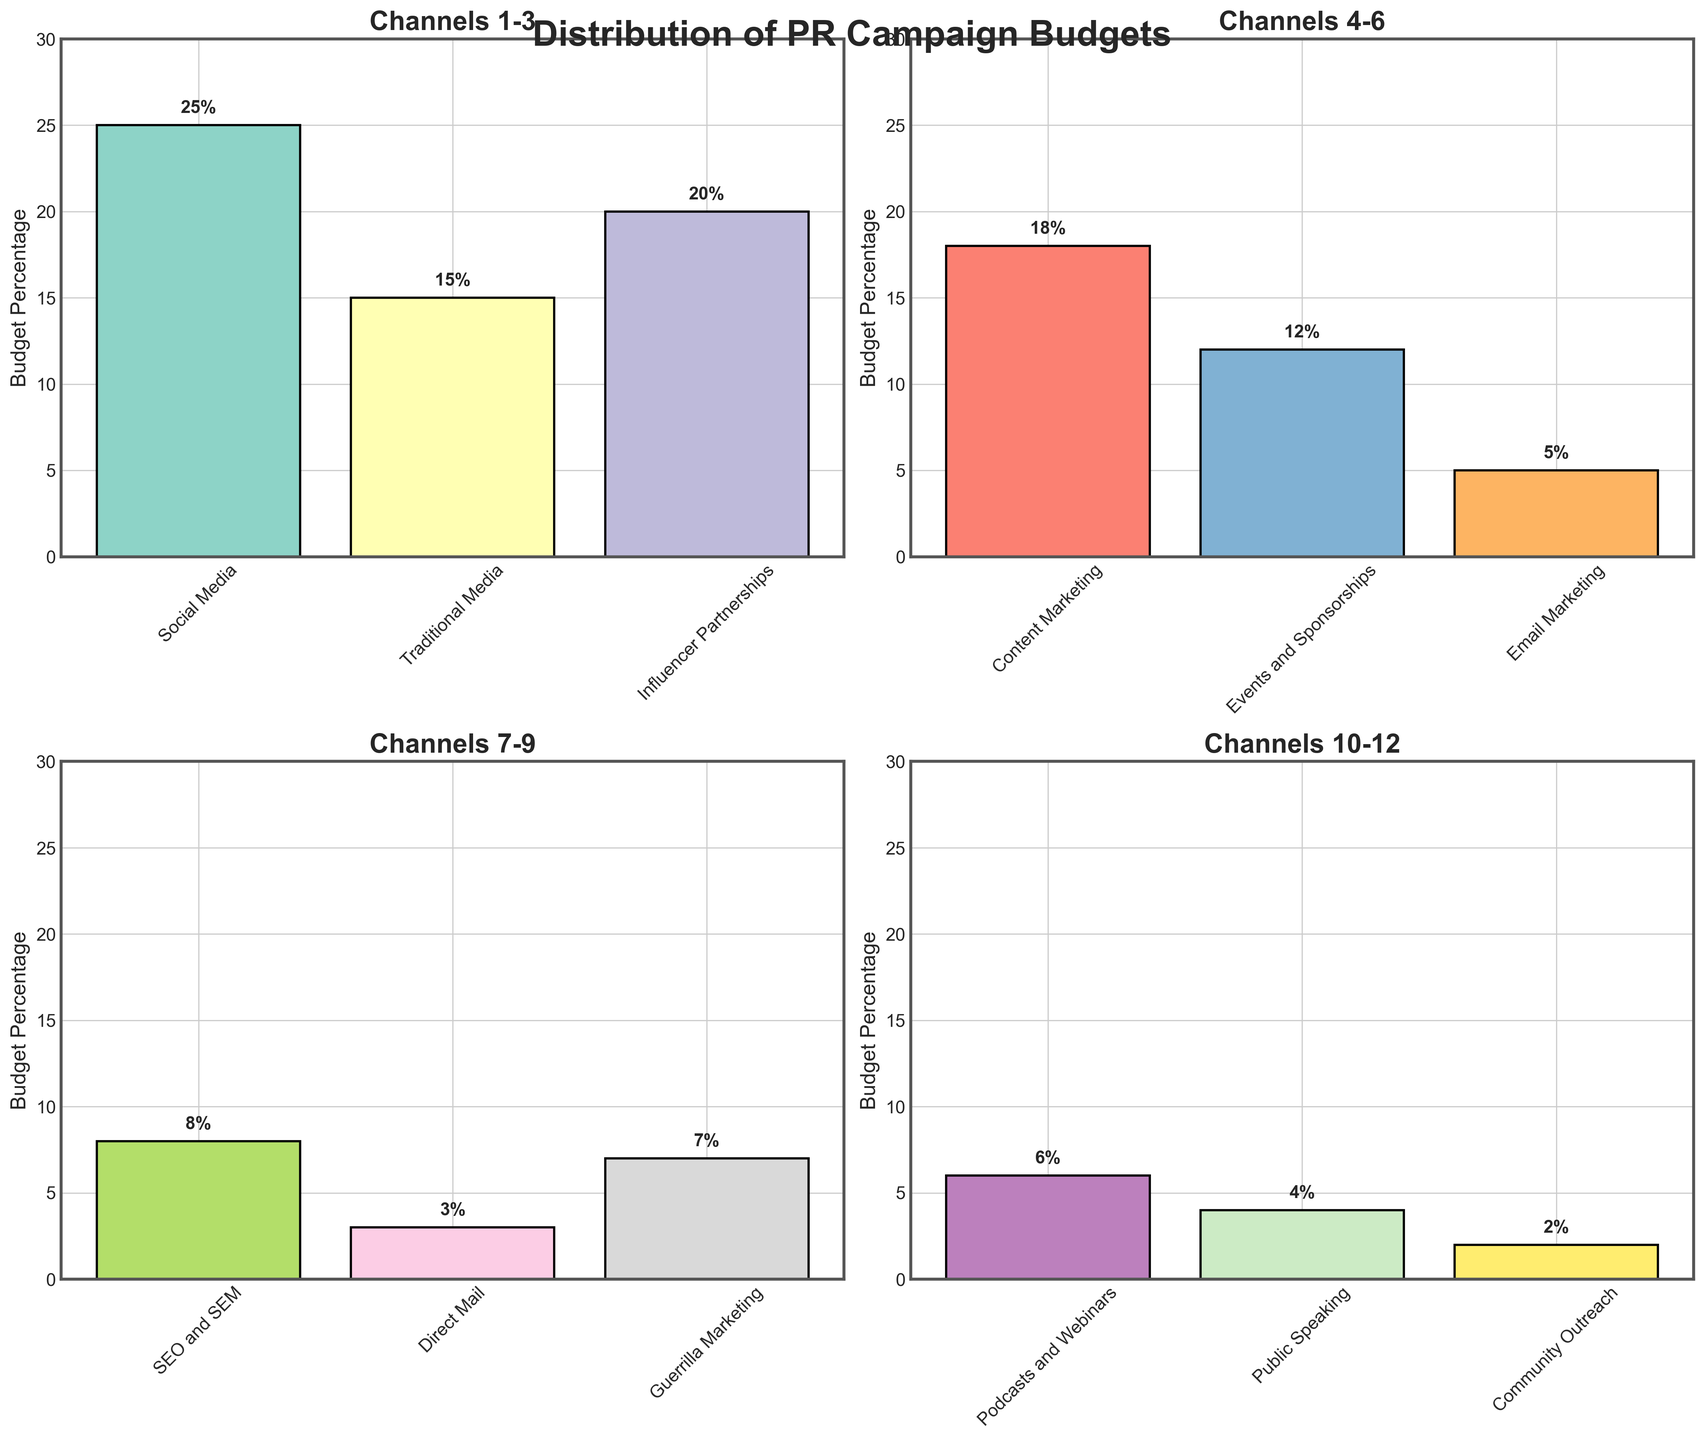What is the title of the overall figure? The title is displayed at the top center of the figure, indicating the main subject.
Answer: Distribution of PR Campaign Budgets Which three channels have the highest budget percentages in the first subplot? Examine the bar heights for the first three channels in the first subplot: Social Media, Traditional Media, and Influencer Partnerships.
Answer: Social Media, Influencer Partnerships, Content Marketing How many channels are displayed in each subplot? Each subplot contains the budgets for three communication channels, as indicated by the labels on the x-axis.
Answer: Three Which subplot shows the highest budget percentage? Compare the tallest bars across each subplot. The first subplot has the tallest bar at 25% for Social Media.
Answer: The first subplot What is the total budget percentage for the channels displayed in the second subplot? Add the budget percentages for the channels in the second subplot: Influencer Partnerships (20%), Content Marketing (18%), and Events and Sponsorships (12%). 20 + 18 + 12 = 50%
Answer: 50% Which channel has the lowest budget percentage and in which subplot is it displayed? Identify the shortest bar across all subplots, which represents Community Outreach at 2% in the fourth subplot.
Answer: Community Outreach, fourth subplot How does the budget percentage for SEO and SEM compare to that of Direct Mail? Compare the heights of the bars for SEO and SEM (8%) and Direct Mail (3%) from the third subplot.
Answer: Higher What is the average budget percentage for channels in the third subplot? Sum the budget percentages for channels in the third subplot: Email Marketing (5%), SEO and SEM (8%), and Direct Mail (3%). Then divide by 3. (5 + 8 + 3) / 3 = 16/3 ≈ 5.33
Answer: Approximately 5.33% What is the sum of percentages of budget for the channels in the last subplot? Add the percentages of budget for the channels in the last subplot: Guerrilla Marketing (7%), Podcasts and Webinars (6%), Public Speaking (4%), and Community Outreach (2%). 7 + 6 + 4 + 2 = 19
Answer: 19% How many unique colors are used in the entire set of subplots? Identify the distinct color for each bar across all subplots. Since there are 12 channels and each one has a unique color, there are 12 unique colors.
Answer: Twelve 